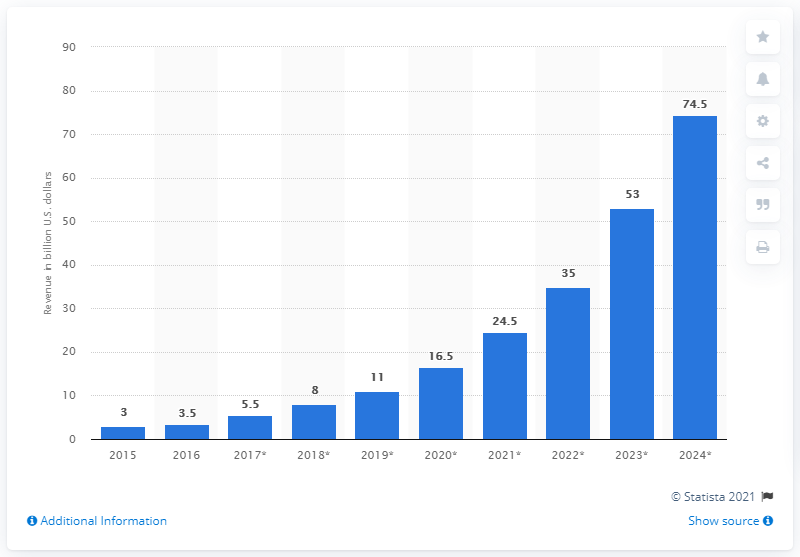Identify some key points in this picture. In 2016, the global market for agricultural robots was estimated to be $3.5 billion. 